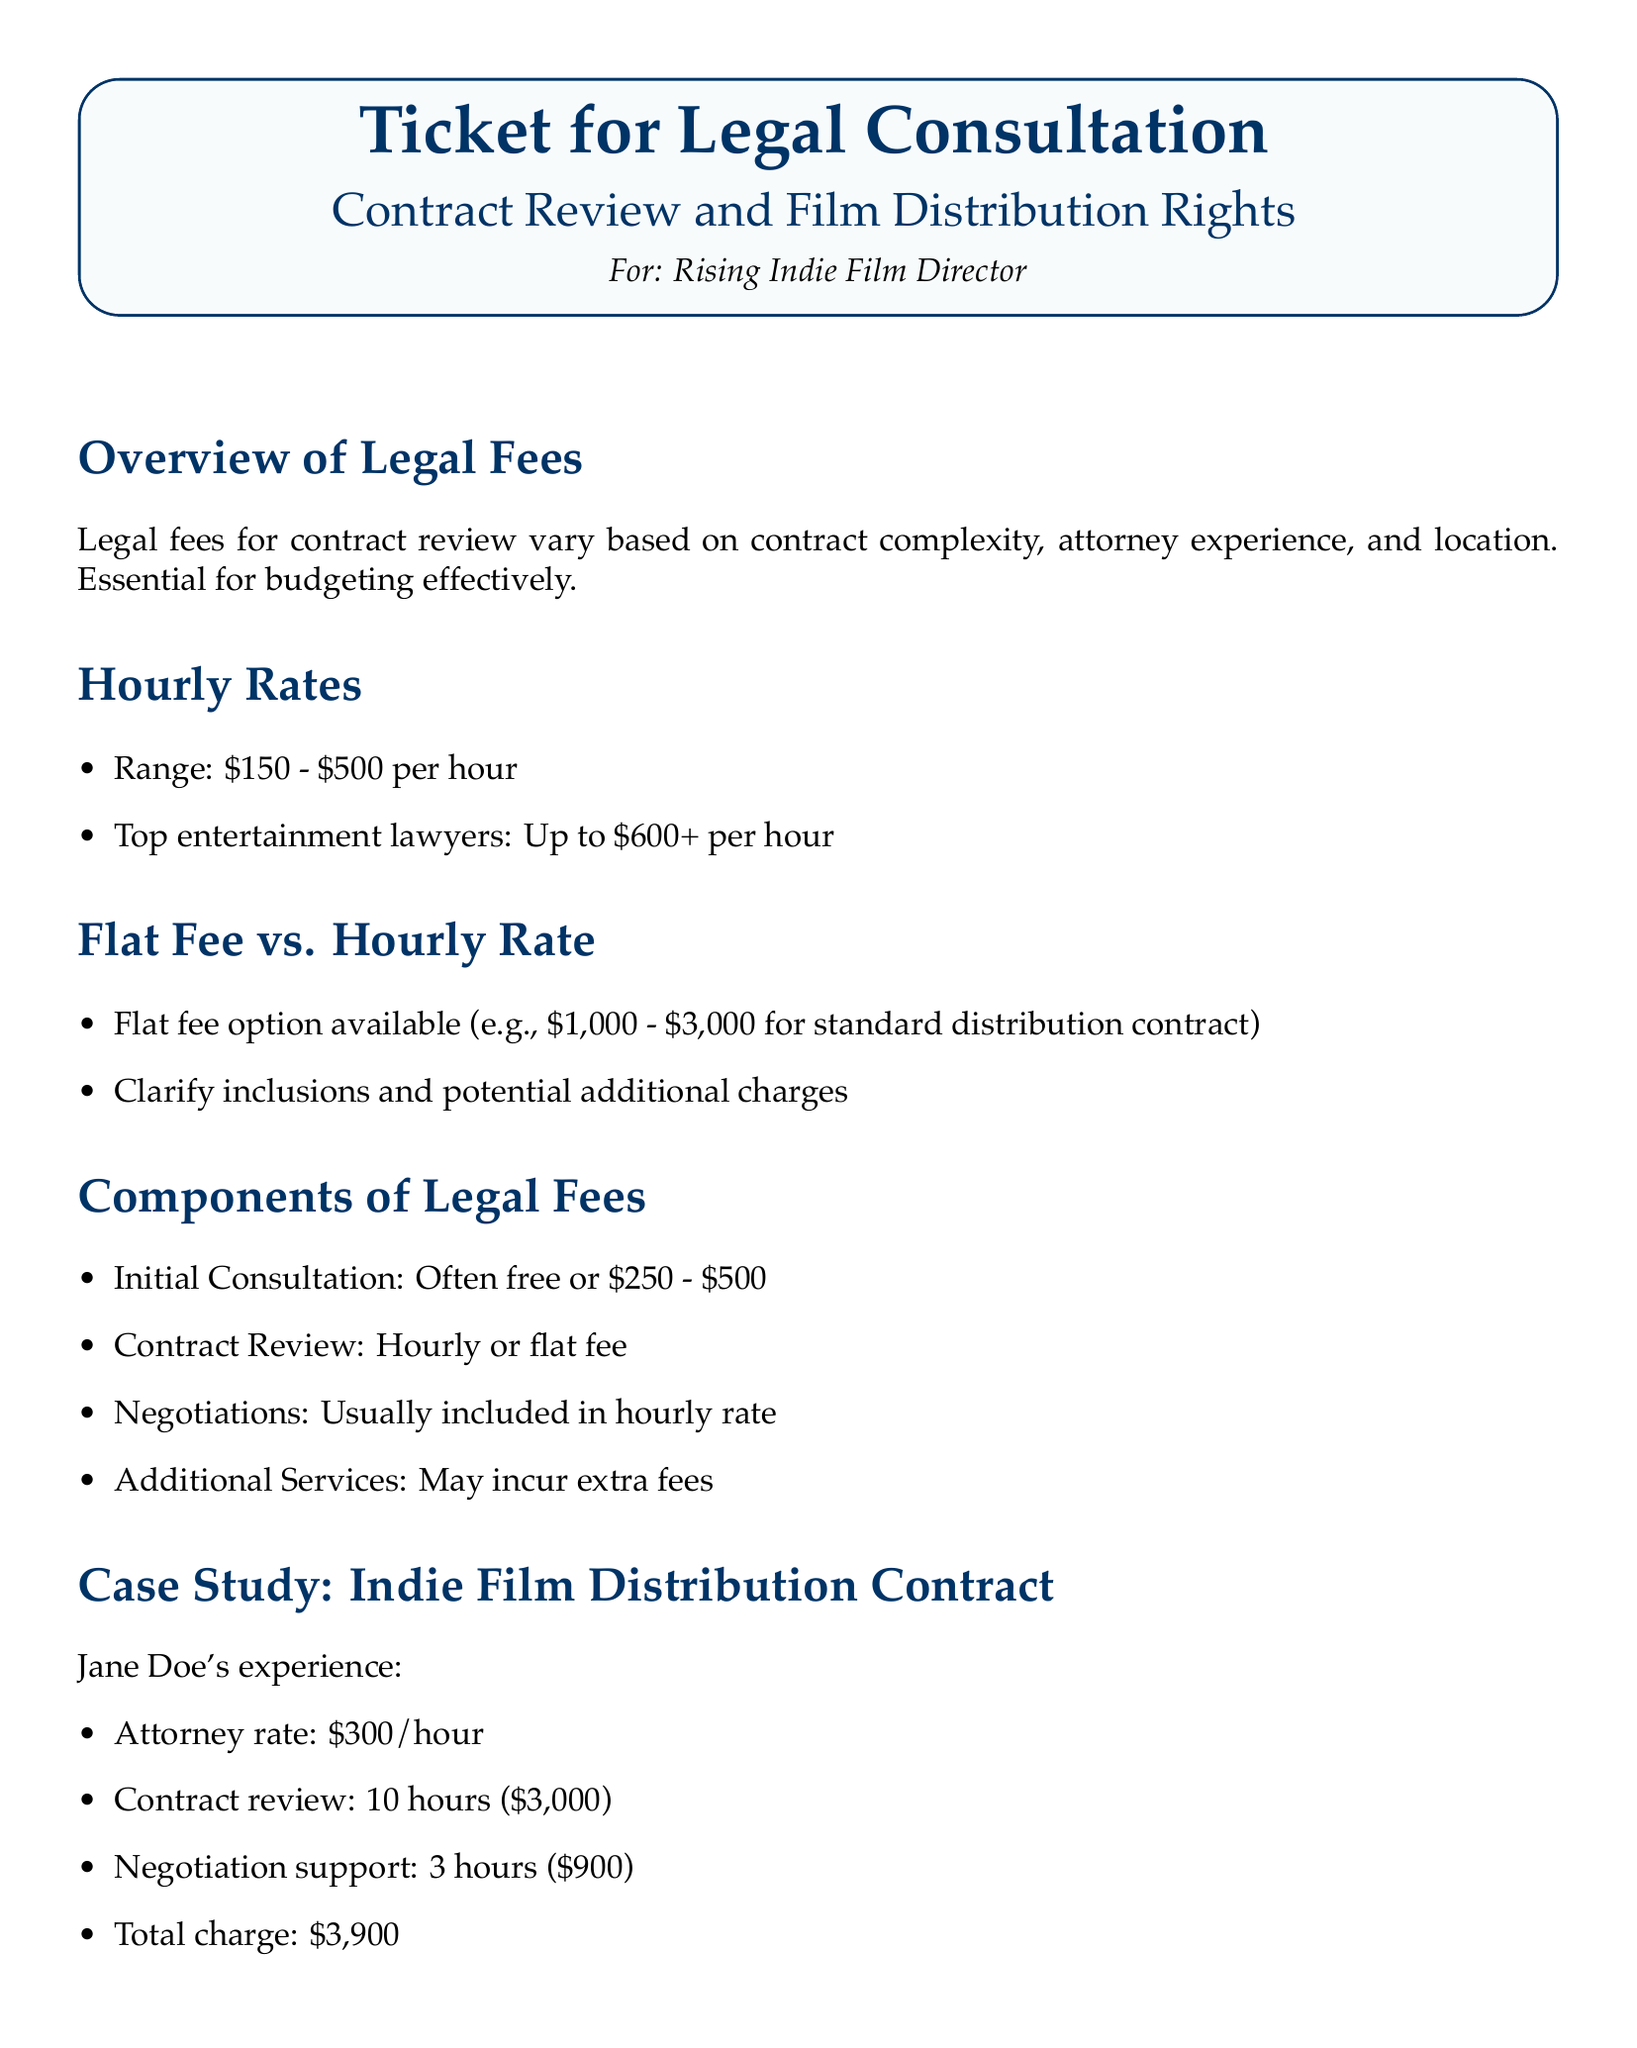What are the hourly rates for legal fees? The document specifies a range of hourly rates for legal fees, which is important for estimating costs.
Answer: $150 - $500 per hour What is the average charge for negotiation support? By analyzing the case study, we see the negotiation support time is charged hourly by the attorney’s rate.
Answer: $900 What was the total charge for Jane Doe's contract review and negotiation? The total charge combines the costs of contract review and negotiation support, detailed in the case study.
Answer: $3,900 What is one component of legal fees mentioned? The document lists several components that contribute to the overall legal fees for contract reviews.
Answer: Contract Review What is the fee range for a standard distribution contract? The document highlights the flat fee option for reviewing distribution contracts is different from hourly rates.
Answer: $1,000 - $3,000 What does "initial consultation" typically cost? The initial consultation costs can be free but vary based on the attorney, as noted in the breakdown.
Answer: $250 - $500 In what type of legal situation is this document relevant? The ticket is aimed specifically at a particular category of clients, indicating its relevance for specific legal needs.
Answer: Independent Film Director What additional consideration is mentioned regarding legal fees? The document advises clients to be aware of hidden costs when assessing legal fees.
Answer: Hidden Costs 